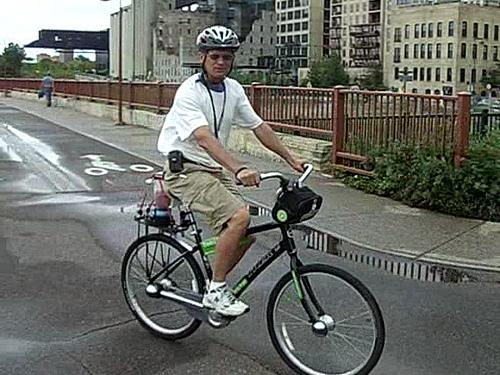What color is the gate?
Write a very short answer. Brown. Where is the helmet?
Quick response, please. Head. Are the roads crowded?
Keep it brief. No. How old is this man?
Give a very brief answer. 50. 